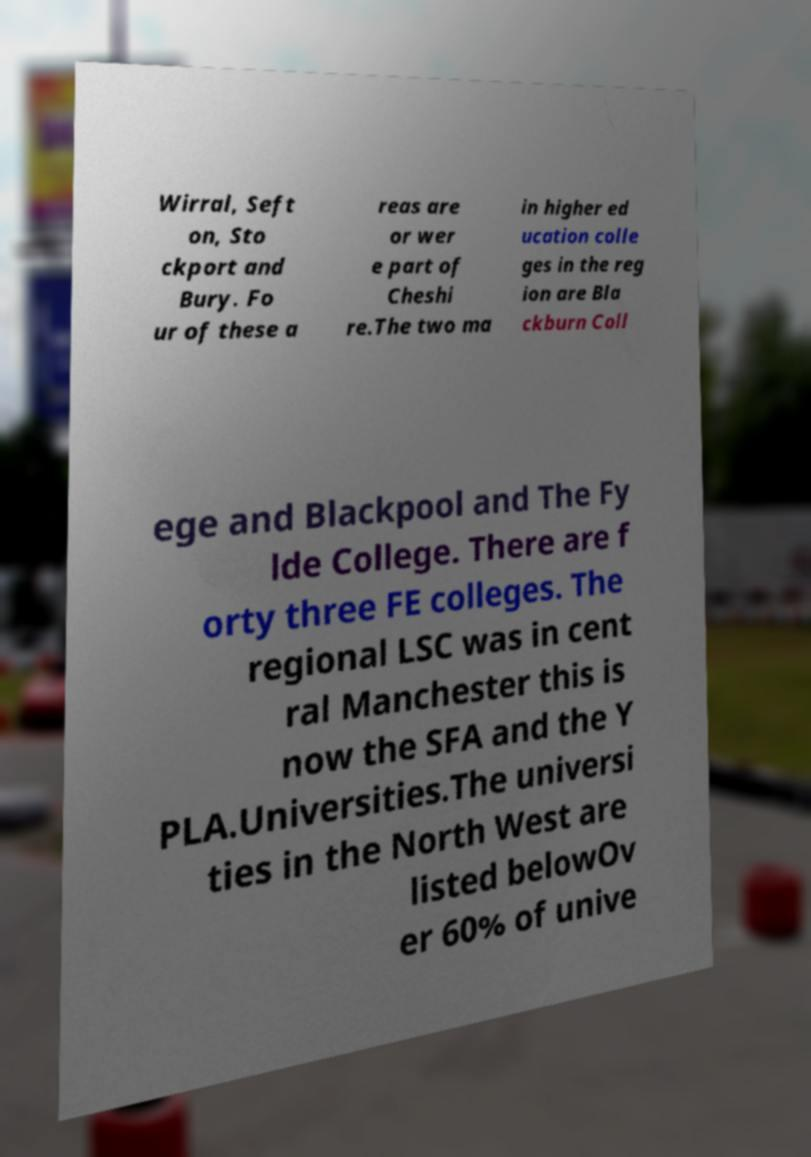Could you assist in decoding the text presented in this image and type it out clearly? Wirral, Seft on, Sto ckport and Bury. Fo ur of these a reas are or wer e part of Cheshi re.The two ma in higher ed ucation colle ges in the reg ion are Bla ckburn Coll ege and Blackpool and The Fy lde College. There are f orty three FE colleges. The regional LSC was in cent ral Manchester this is now the SFA and the Y PLA.Universities.The universi ties in the North West are listed belowOv er 60% of unive 